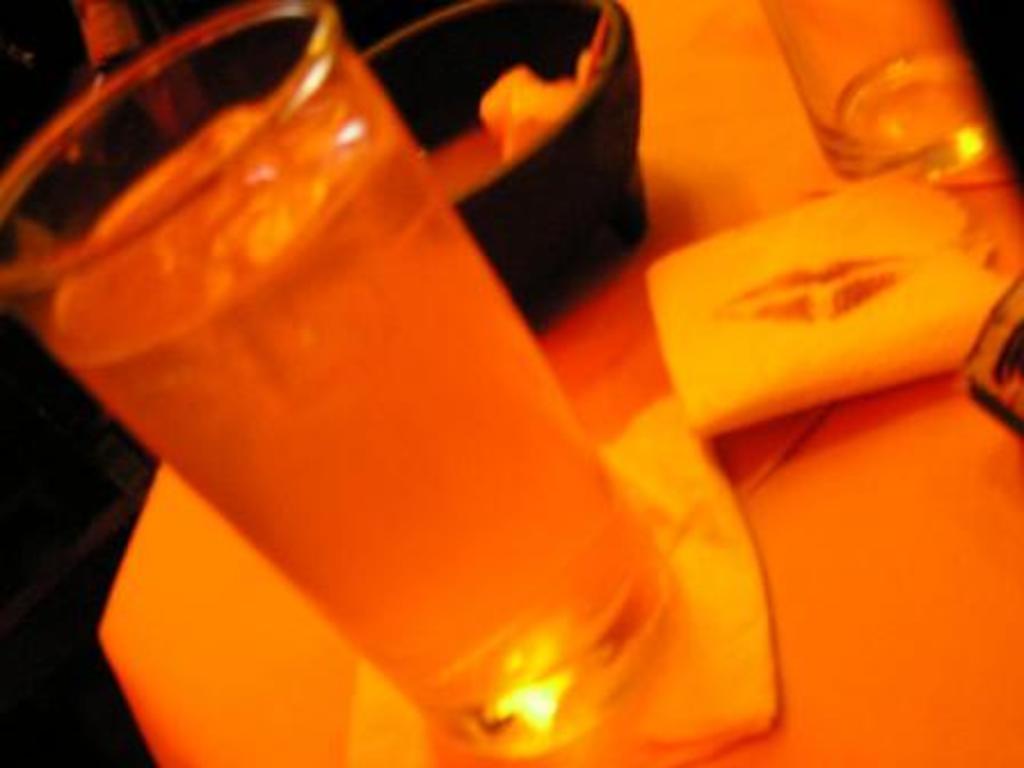Describe this image in one or two sentences. On this surface we can see a bowl, glasses and tissue papers. In this glass there is a liquid. 